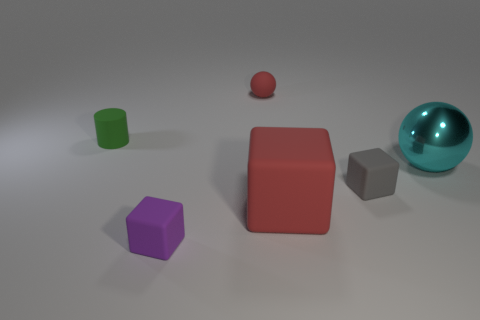Add 2 small purple matte things. How many objects exist? 8 Subtract all small purple cubes. Subtract all big red rubber objects. How many objects are left? 4 Add 4 small purple matte things. How many small purple matte things are left? 5 Add 2 green metallic cylinders. How many green metallic cylinders exist? 2 Subtract 0 blue spheres. How many objects are left? 6 Subtract all cylinders. How many objects are left? 5 Subtract all brown blocks. Subtract all gray cylinders. How many blocks are left? 3 